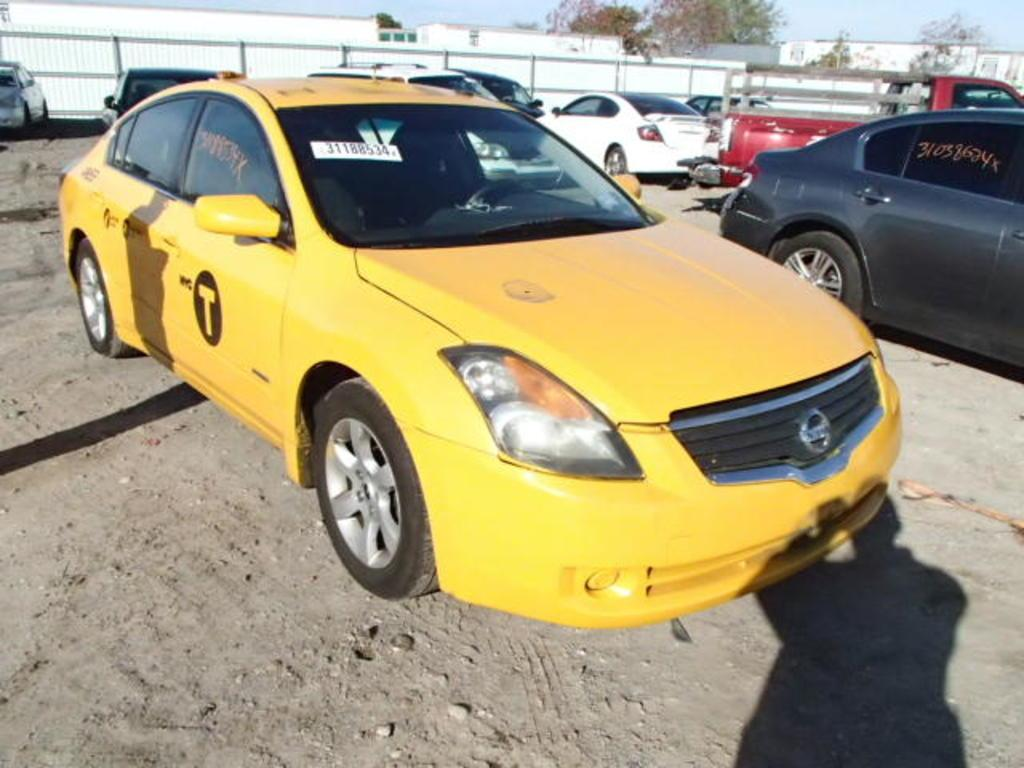<image>
Create a compact narrative representing the image presented. The yellow car that is parked has the letter T on the side door. 